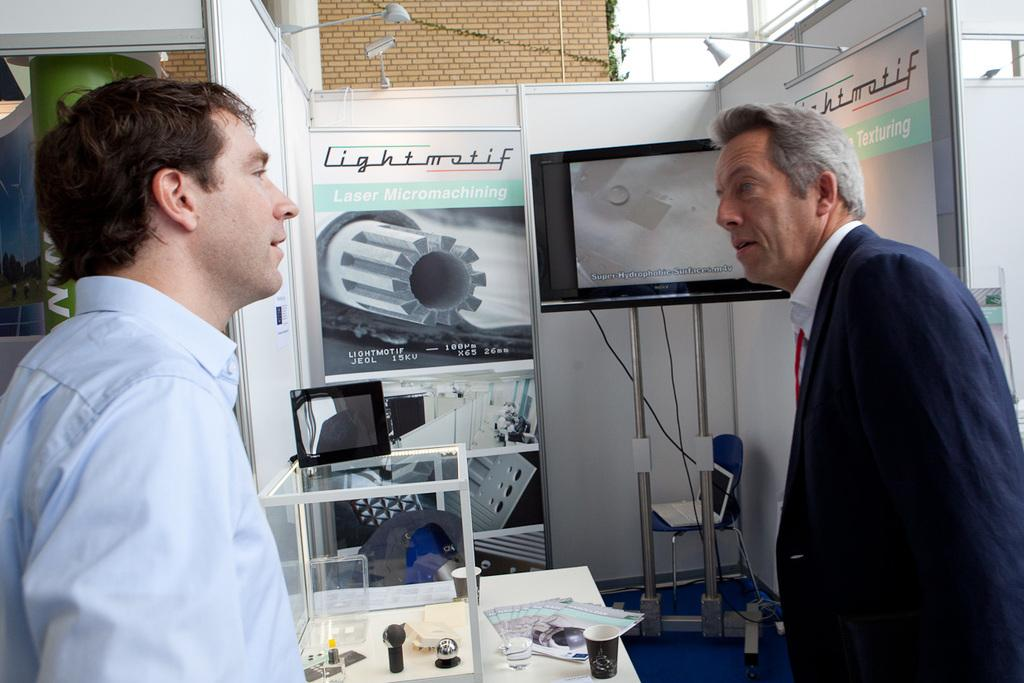How many men are in the image? There are two men in the image. What are the men wearing? The men are wearing clothes. Can you describe the screen in the image? There is a screen in the image, but its specific details are not mentioned. What is the poster depicting? The content of the poster is not mentioned, but there is a poster in the image. Can you describe the light in the image? There is a light in the image, but its specific details are not mentioned. What is the background of the image made of? The background of the image features a brick wall. What is the floor made of? The floor's material is not mentioned. What is the paper used for in the image? The purpose of the paper in the image is not mentioned. What is inside the cup? The contents of the cup are not mentioned. What is inside the glass box? The contents of the glass box are not mentioned. What is the cable wire connected to? The cable wire's connection is not mentioned. What is the stand supporting? The purpose or object supported by the stand is not mentioned. What type of leaves are in the image? The type of leaves is not mentioned. What type of metal is used to make the sweater in the image? There is no sweater present in the image. How does the zephyr affect the men in the image? There is no mention of a zephyr or any wind in the image. 